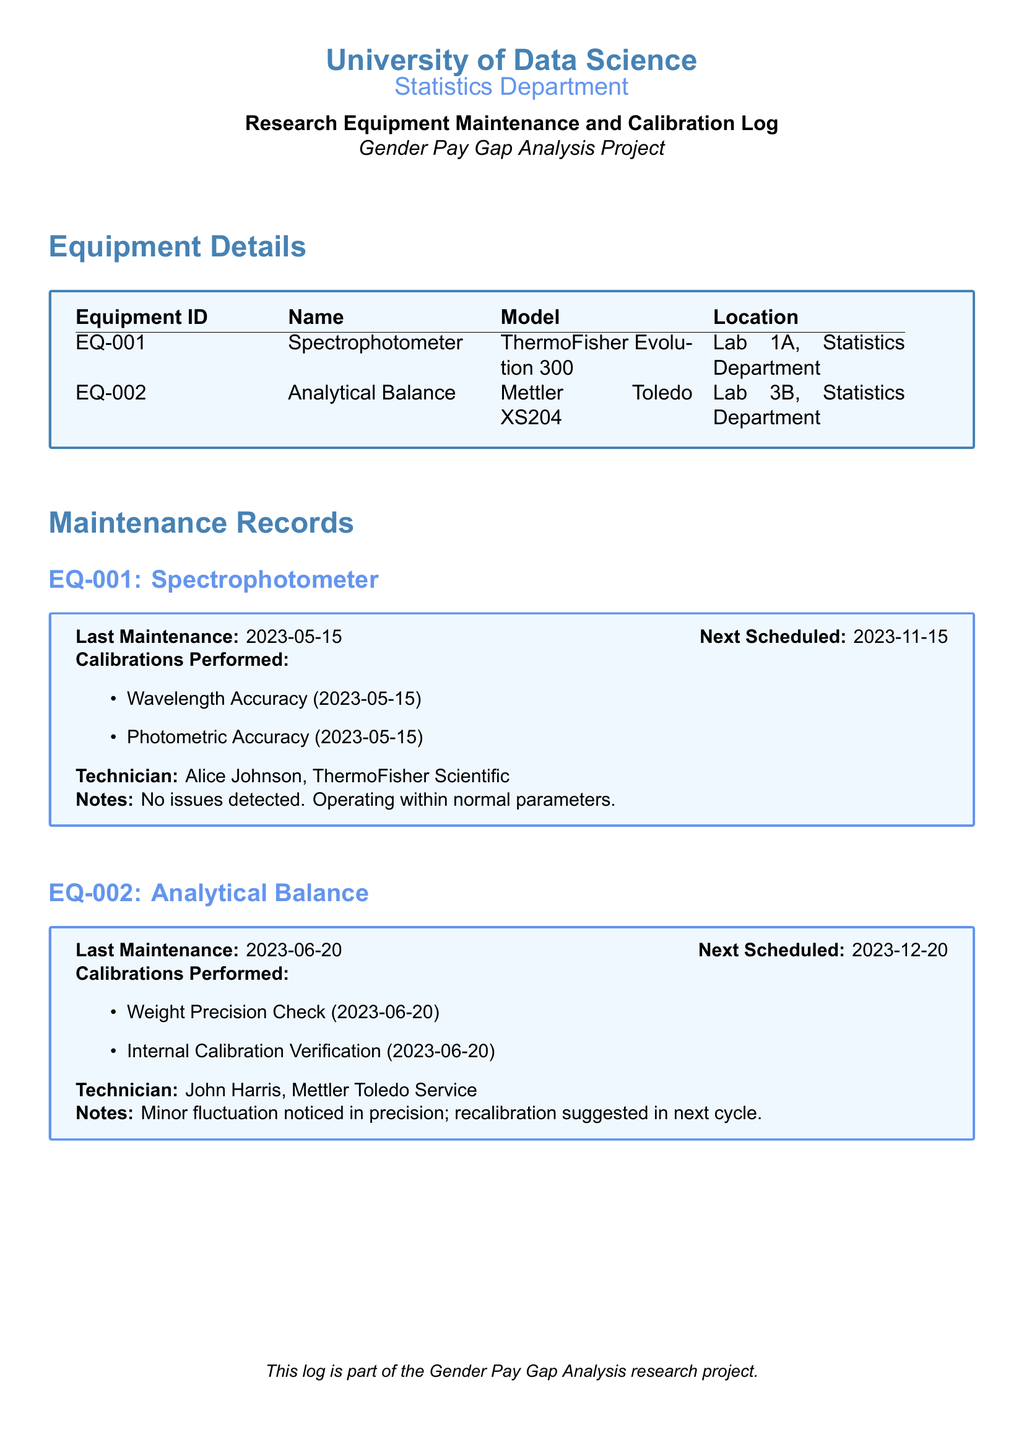What is the Equipment ID for the Spectrophotometer? The Equipment ID for the Spectrophotometer is listed as EQ-001 in the document.
Answer: EQ-001 Who performed the last calibration for the Analytical Balance? The last calibration for the Analytical Balance was performed by John Harris from Mettler Toledo Service, as noted in the document.
Answer: John Harris When is the next scheduled maintenance for the Spectrophotometer? The next scheduled maintenance for the Spectrophotometer is on 2023-11-15, as mentioned in the maintenance records.
Answer: 2023-11-15 What calibration was performed on the Spectrophotometer? The document states that wavelength accuracy and photometric accuracy were both performed on the Spectrophotometer during its last maintenance.
Answer: Wavelength Accuracy, Photometric Accuracy Was any issue detected during the last maintenance of the Spectrophotometer? The notes in the maintenance log indicate that no issues were detected during the last maintenance of the Spectrophotometer.
Answer: No issues detected What minor issue was noted for the Analytical Balance? The maintenance log mentions that a minor fluctuation in precision was noticed during the last maintenance of the Analytical Balance.
Answer: Minor fluctuation in precision When was the last maintenance performed on the Analytical Balance? The last maintenance on the Analytical Balance was performed on 2023-06-20, which is clearly stated in the maintenance records.
Answer: 2023-06-20 Which equipment's location is listed as Lab 3B, Statistics Department? The document specifies that the Analytical Balance is located in Lab 3B, Statistics Department.
Answer: Analytical Balance What is the purpose of this log? The log states that it is part of the Gender Pay Gap Analysis research project, indicating its purpose relates to this specific research initiative.
Answer: Gender Pay Gap Analysis Project 